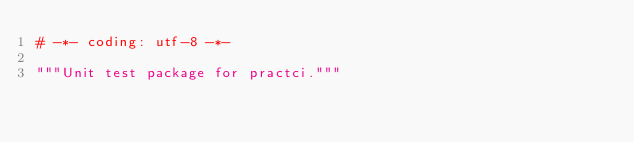Convert code to text. <code><loc_0><loc_0><loc_500><loc_500><_Python_># -*- coding: utf-8 -*-

"""Unit test package for practci."""
</code> 